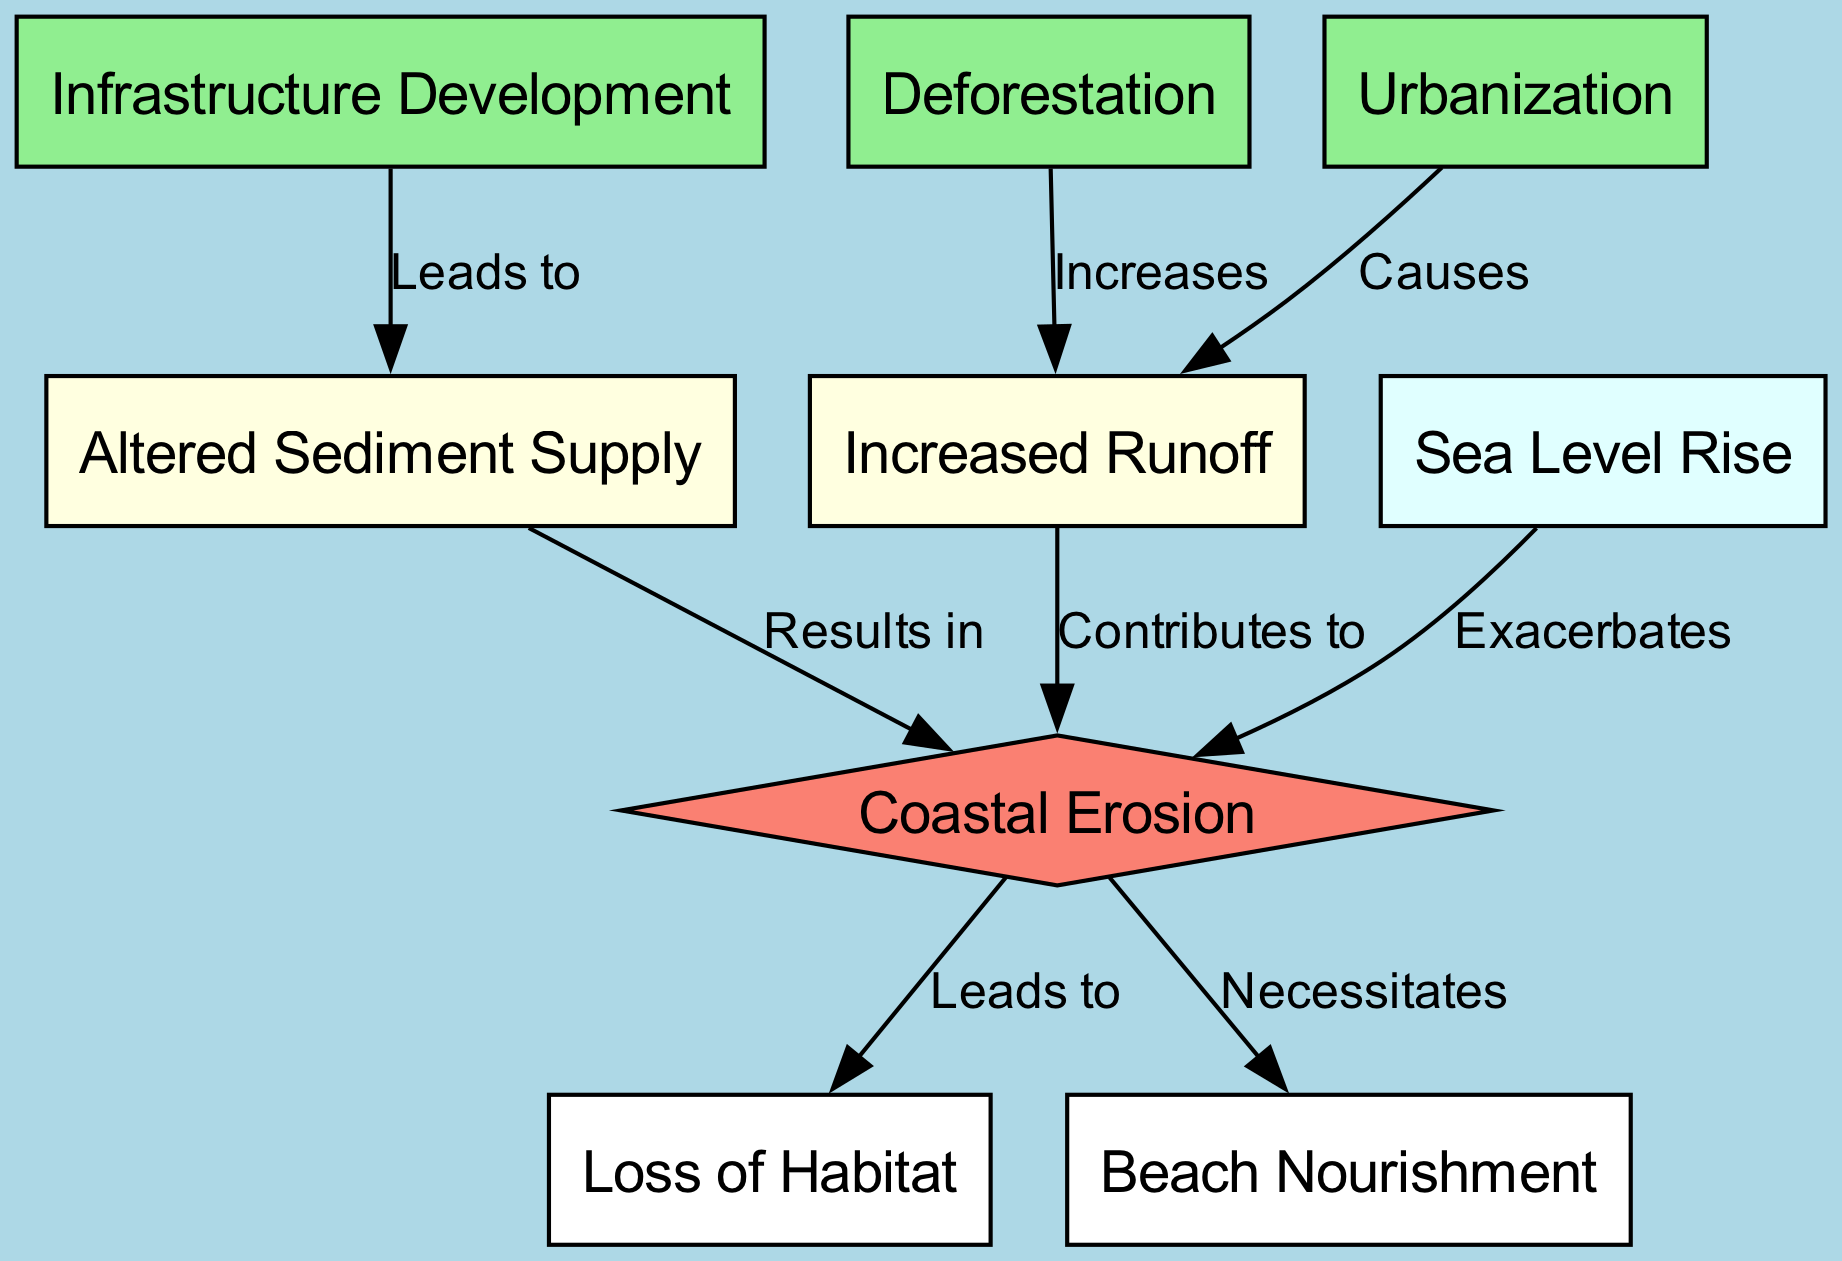What is the total number of nodes in the diagram? The diagram contains a total of eight nodes which represent different factors contributing to coastal erosion. By counting each distinct node listed, we arrive at the total.
Answer: 8 Which node is highlighted in salmon color? The node representing "Coastal Erosion" is specifically indicated in salmon color, identifying it as a key point within the diagram.
Answer: Coastal Erosion How many edges contribute to coastal erosion? There are five edges directed towards the "Coastal Erosion" node from various sources, indicating multiple contributing factors to coastal erosion. These edges represent relationships from other nodes.
Answer: 5 What is the relationship between urbanization and increased runoff? The diagram illustrates that urbanization causes increased runoff; this causal relationship is represented by a directed edge labeled "Causes" connecting the two nodes.
Answer: Causes Which factor exacerbates coastal erosion? The factor that exacerbates coastal erosion is "Sea Level Rise," which is explicitly stated as having a direct influence on increasing the rate of coastal erosion in the diagram.
Answer: Sea Level Rise What leads to altered sediment supply? "Infrastructure Development" is the factor that leads to altered sediment supply, as indicated by the directed edge labeled "Leads to" connecting the two nodes in the diagram.
Answer: Infrastructure Development How does deforestation affect increased runoff? Deforestation increases runoff; this is a direct relationship shown in the diagram where the edge is labeled "Increases," illustrating the impact of deforestation on the hydrological dynamics.
Answer: Increases Which effect does coastal erosion necessitate? The necessity created by coastal erosion is for "Beach Nourishment," as indicated by the directed edge labeled "Necessitates," highlighting the response to coastal erosion's effects.
Answer: Beach Nourishment 